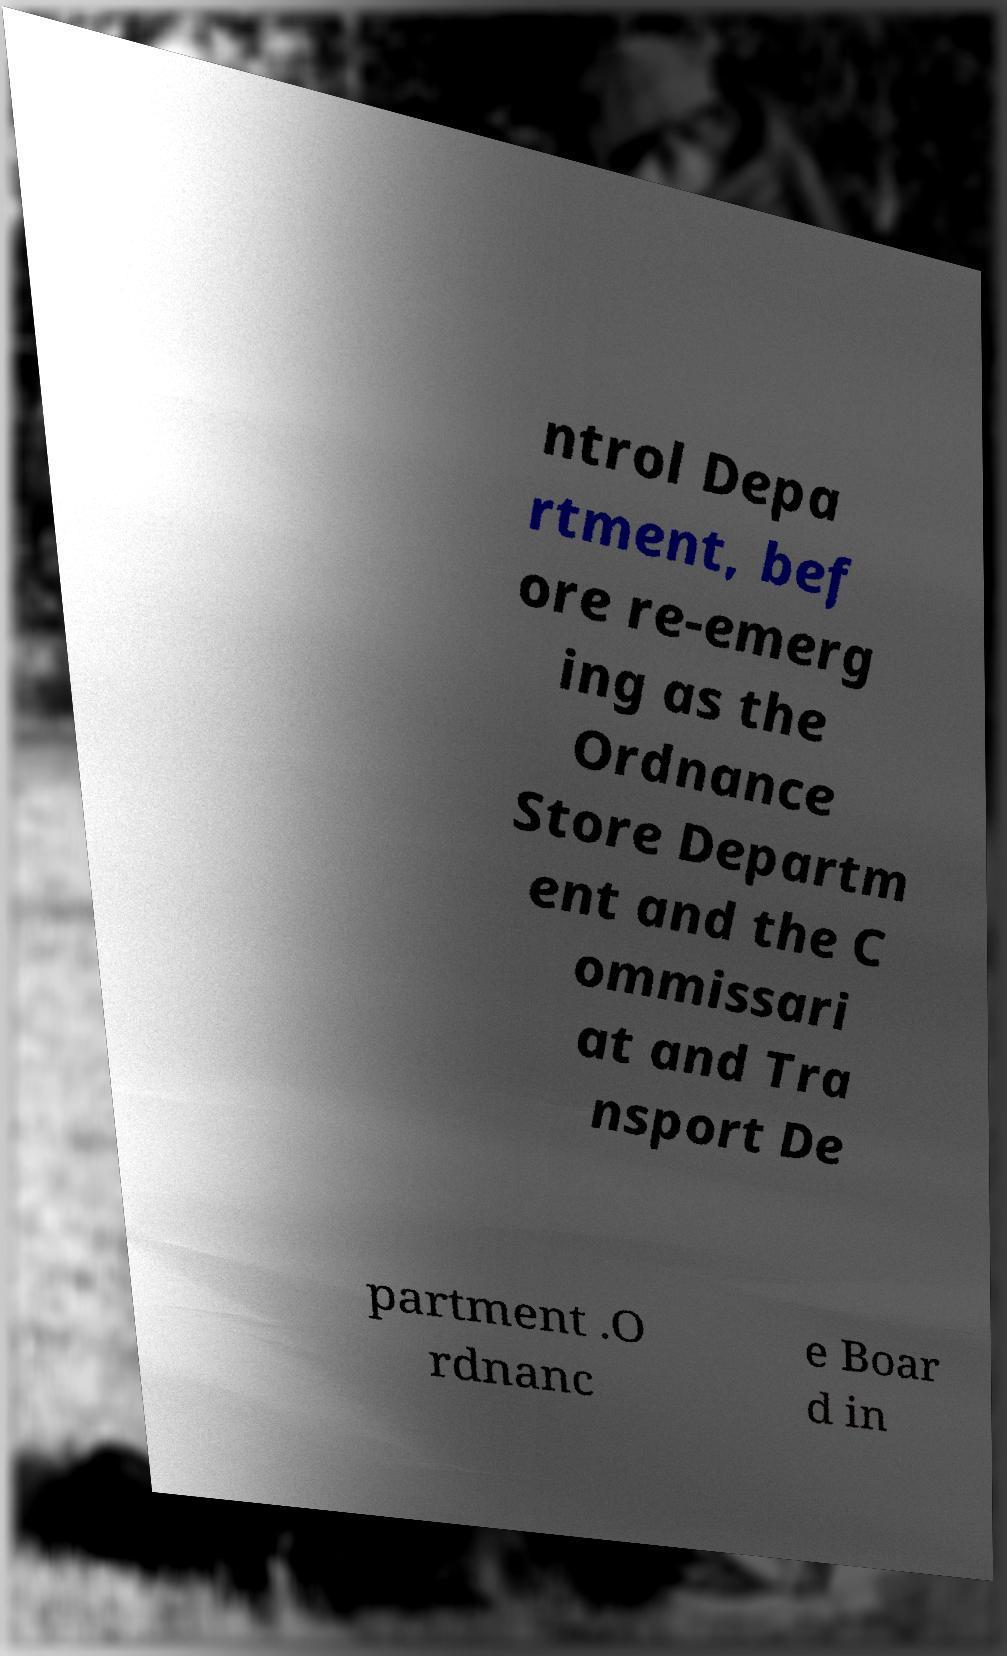What messages or text are displayed in this image? I need them in a readable, typed format. ntrol Depa rtment, bef ore re-emerg ing as the Ordnance Store Departm ent and the C ommissari at and Tra nsport De partment .O rdnanc e Boar d in 